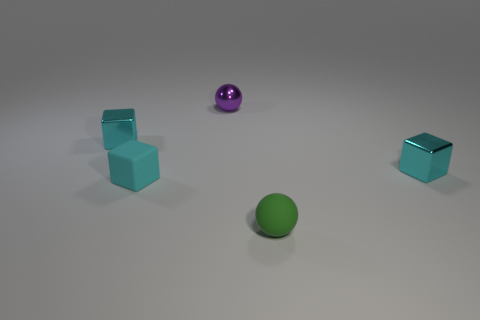Can you tell me what colors the objects in the image are? Certainly! There are two balls, one is green and the other is purple. In addition, there are two cubes that are a light blue color. 